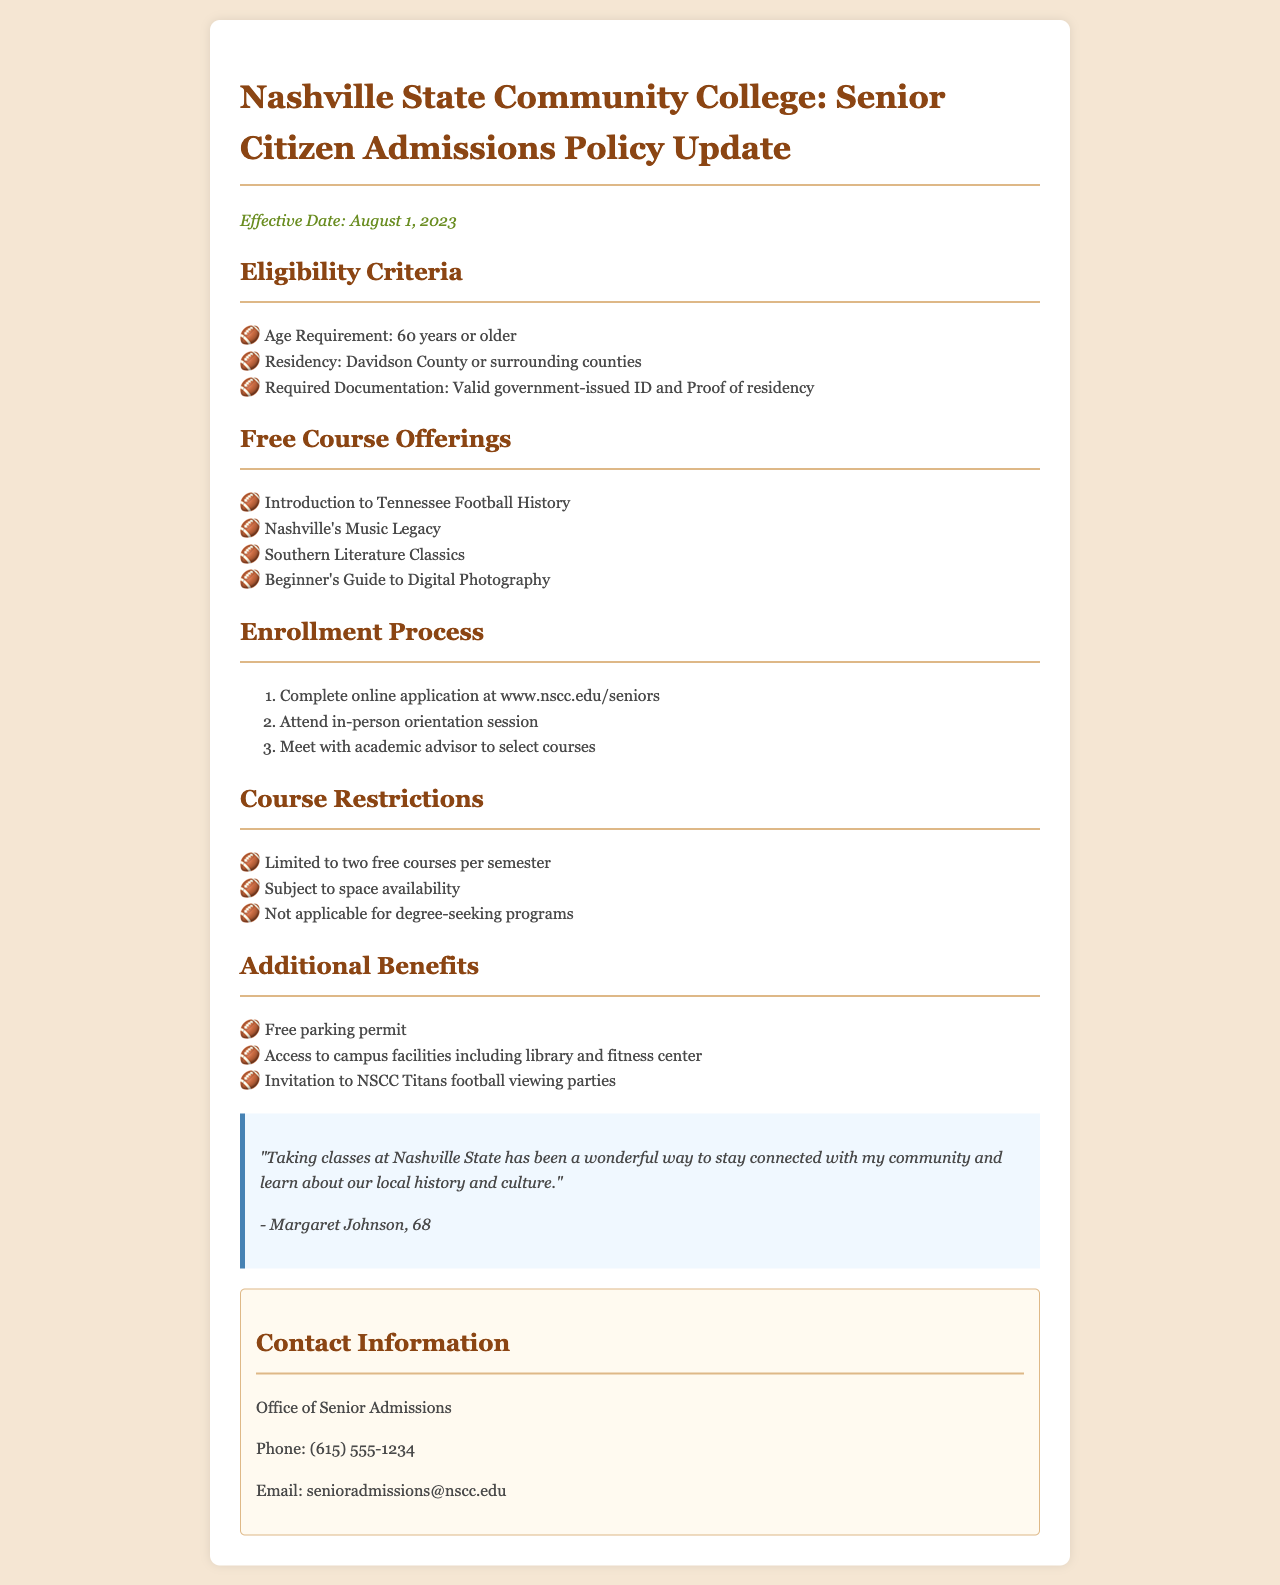What is the effective date of the policy? The effective date is stated clearly at the top of the document.
Answer: August 1, 2023 What is the age requirement for eligibility? The eligibility criteria list the age requirement for senior citizens applying.
Answer: 60 years or older What are the free course offerings? The document lists specific courses available to seniors.
Answer: Introduction to Tennessee Football History, Nashville's Music Legacy, Southern Literature Classics, Beginner's Guide to Digital Photography How many free courses can seniors take per semester? The course restrictions section specifies this limit.
Answer: Two What is required for residency eligibility? The eligibility criteria mention residency requirements for applicants.
Answer: Davidson County or surrounding counties What is the contact phone number for the Office of Senior Admissions? The contact information section includes this phone number.
Answer: (615) 555-1234 What type of events are seniors invited to? The additional benefits section describes events that are available to seniors.
Answer: NSCC Titans football viewing parties What is required as proof of residency? The eligibility criteria outline documentation requirements for residency.
Answer: Proof of residency What should seniors do after completing the online application? The enrollment process outlines steps needed post-application.
Answer: Attend in-person orientation session 